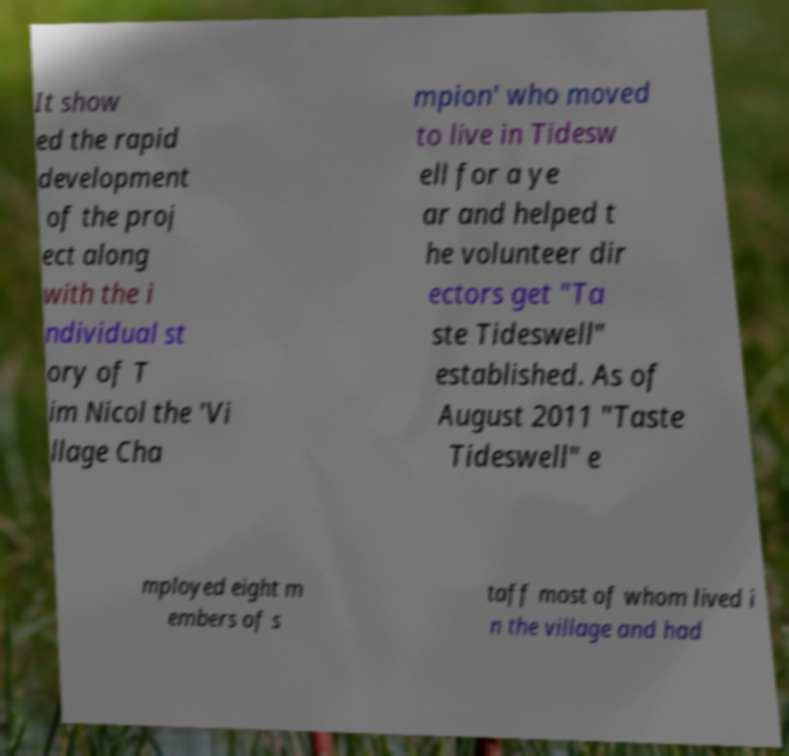For documentation purposes, I need the text within this image transcribed. Could you provide that? It show ed the rapid development of the proj ect along with the i ndividual st ory of T im Nicol the 'Vi llage Cha mpion' who moved to live in Tidesw ell for a ye ar and helped t he volunteer dir ectors get "Ta ste Tideswell" established. As of August 2011 "Taste Tideswell" e mployed eight m embers of s taff most of whom lived i n the village and had 